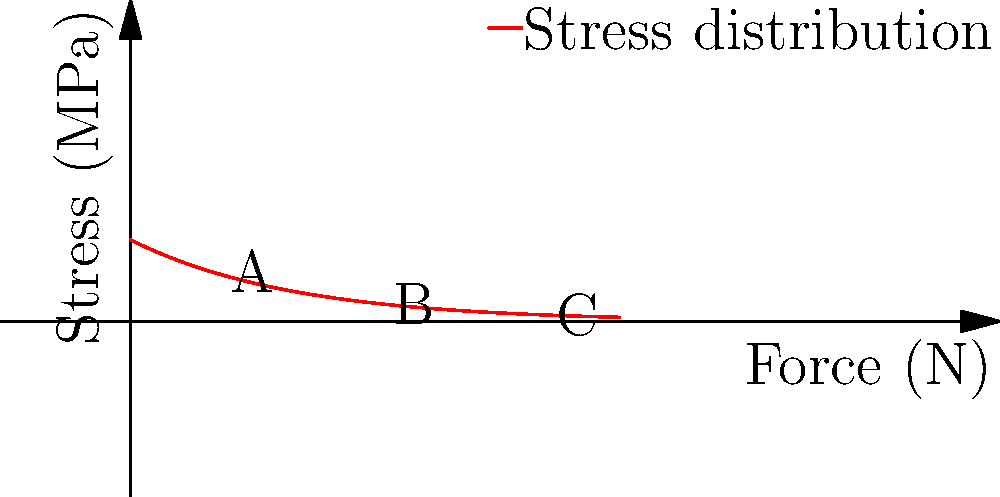As a social media strategist for a non-profit organization focused on prosthetic research, you're creating content to educate followers about biomechanics. The graph shows the stress distribution on a prosthetic limb under various loading conditions. If the maximum allowable stress for the prosthetic material is 30 MPa, what is the approximate maximum force that can be safely applied before risking material failure? To determine the maximum safe force, we need to follow these steps:

1. Identify the stress limit: The maximum allowable stress is given as 30 MPa.

2. Analyze the graph: The curve represents stress (y-axis) as a function of applied force (x-axis).

3. Find the intersection: We need to find where the curve intersects with a horizontal line at y = 30 MPa.

4. Estimate the force: By visual inspection, the curve intersects the 30 MPa line at approximately 120 N.

5. Interpret the result: This means that applying a force of about 120 N would result in a maximum stress of 30 MPa in the prosthetic limb.

6. Consider safety factor: In practice, we might want to apply a safety factor to ensure we're well below the failure point. A common safety factor is 1.5, which would reduce the safe force to:

   $$\frac{120 \text{ N}}{1.5} \approx 80 \text{ N}$$

Therefore, to maintain a conservative approach in our public communication, we should report the maximum safe force as approximately 80 N.
Answer: 80 N 